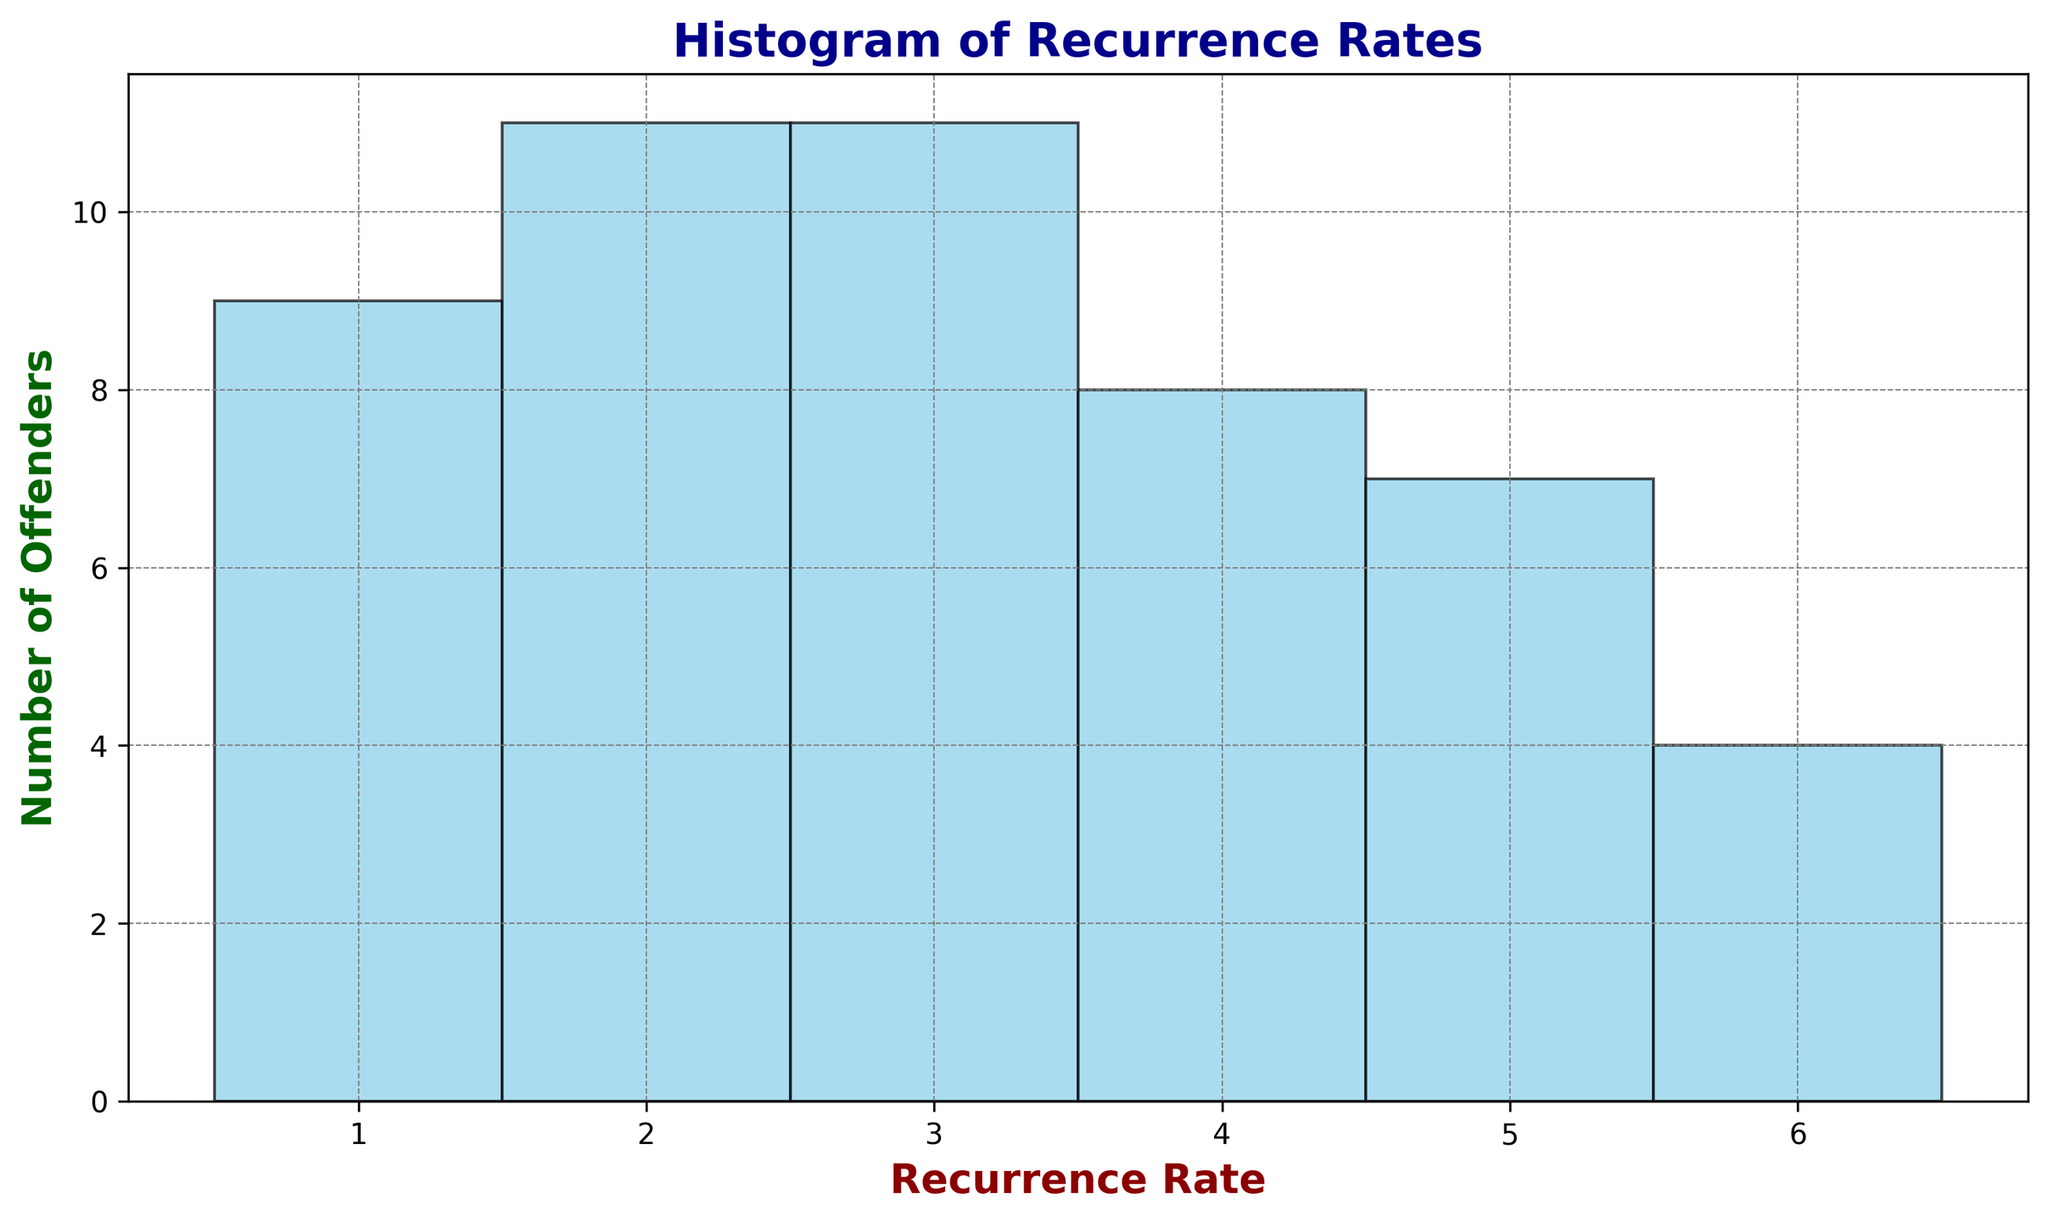What's the most common recurrence rate among offenders? By looking at the histogram, the bar that has the greatest height represents the most common recurrence rate. The highest bar corresponds to the recurrence rate of 3.
Answer: 3 Which recurrence rate has the fewest number of offenders? The shortest bar in the histogram indicates the recurrence rate with the fewest number of offenders. The bar corresponding to a recurrence rate of 6 is the shortest.
Answer: 6 How many offenders have a recurrence rate of 4? The height of the bar for a recurrence rate of 4 shows the number of offenders. By counting the units on the y-axis for this bar, we can see that there are 8 offenders.
Answer: 8 What's the total number of offenders with a recurrence rate of 1 or 2? Adding the heights of the bars for recurrence rates of 1 and 2, we find that there are 7 offenders with a rate of 1 and 10 offenders with a rate of 2. So the total is 7 + 10 = 17.
Answer: 17 How does the number of offenders with a recurrence rate of 5 compare to those with a rate of 6? By comparing the heights of the bars for rates 5 and 6, the bar for rate 5 is slightly taller than the bar for rate 6. Rate 5 has 8 offenders, and rate 6 has 6 offenders.
Answer: Rate 5 has more Are there more offenders with a recurrence rate greater than or equal to 4 or those with a rate less than 4? Count the heights of the bars for rates 4, 5, 6 (greater than or equal to 4) and sum them, which gives 8 (rate 4) + 8 (rate 5) + 6 (rate 6) = 22. Then, count the bars for rates 1, 2, 3 (less than 4) and sum, which gives 7 (rate 1) + 10 (rate 2) + 12 (rate 3) = 29.
Answer: Less than 4 What percentage of offenders have a recurrence rate of exactly 3? The number of offenders with a recurrence rate of 3 is represented by the height of the corresponding bar, which is 12. Out of 50 offenders, the percentage is (12/50) * 100 = 24%.
Answer: 24% What's the range of recurrence rates shown in the histogram? The histogram bars start at a minimum value of 1 and go up to a maximum value of 6, so the range is from 1 to 6.
Answer: 1 to 6 